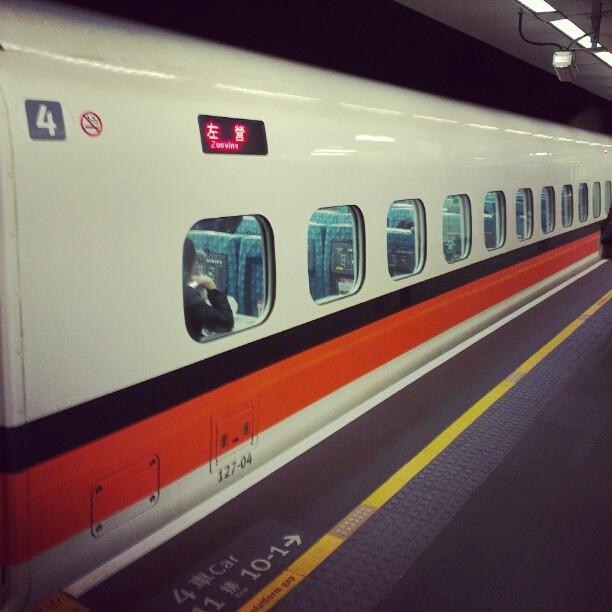Does the train look old?
Answer briefly. No. What is the number in the blue box on the train?
Quick response, please. 4. Are there people on the platform?
Keep it brief. No. How many windows on the train?
Be succinct. 11. What number is on the train?
Give a very brief answer. 4. 